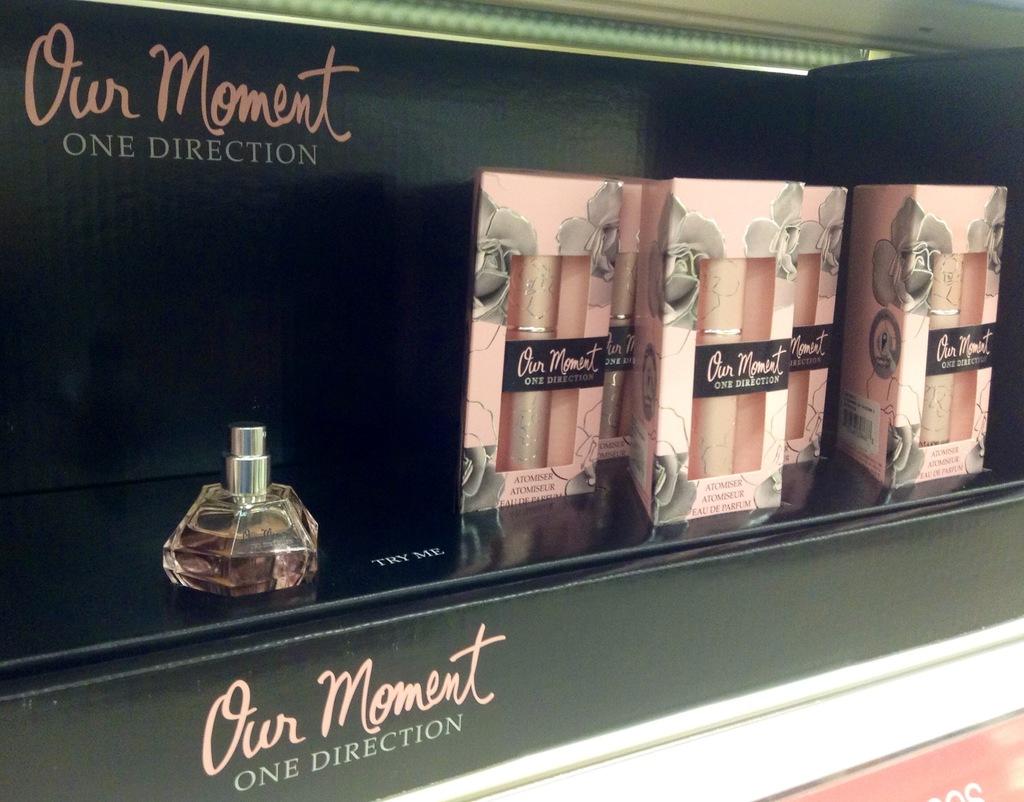What is the name of this perfume?
Make the answer very short. Our moment. 